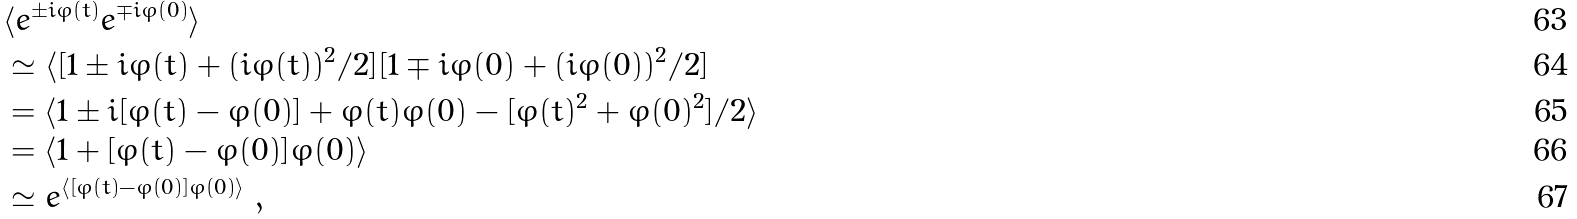<formula> <loc_0><loc_0><loc_500><loc_500>& \langle e ^ { \pm i \varphi ( t ) } e ^ { \mp i \varphi ( 0 ) } \rangle \\ & \simeq \langle [ 1 \pm i \varphi ( t ) + ( i \varphi ( t ) ) ^ { 2 } / 2 ] [ 1 \mp i \varphi ( 0 ) + ( i \varphi ( 0 ) ) ^ { 2 } / 2 ] \\ & = \langle 1 \pm i [ \varphi ( t ) - \varphi ( 0 ) ] + \varphi ( t ) \varphi ( 0 ) - [ \varphi ( t ) ^ { 2 } + \varphi ( 0 ) ^ { 2 } ] / 2 \rangle \\ & = \langle 1 + [ \varphi ( t ) - \varphi ( 0 ) ] \varphi ( 0 ) \rangle \\ & \simeq e ^ { \langle [ \varphi ( t ) - \varphi ( 0 ) ] \varphi ( 0 ) \rangle } \ ,</formula> 